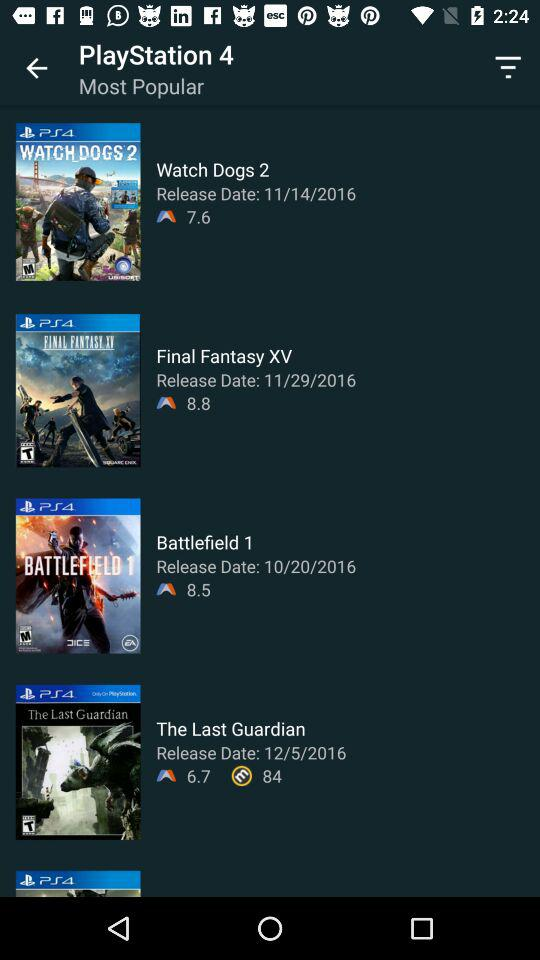Which game has a release date of November 14, 2016? The game that has a release date of November 14, 2016 is "Watch Dogs 2". 